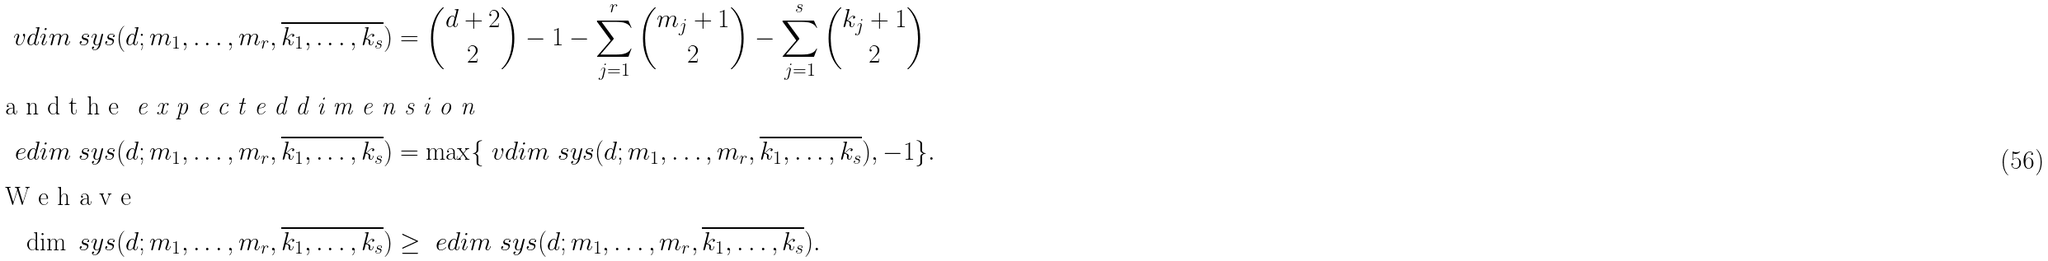Convert formula to latex. <formula><loc_0><loc_0><loc_500><loc_500>\ v d i m \ s y s ( d ; m _ { 1 } , \dots , m _ { r } , \overline { k _ { 1 } , \dots , k _ { s } } ) & = \binom { d + 2 } { 2 } - 1 - \sum _ { j = 1 } ^ { r } \binom { m _ { j } + 1 } { 2 } - \sum _ { j = 1 } ^ { s } \binom { k _ { j } + 1 } { 2 } \\ \intertext { a n d t h e \emph { e x p e c t e d d i m e n s i o n } } \ e d i m \ s y s ( d ; m _ { 1 } , \dots , m _ { r } , \overline { k _ { 1 } , \dots , k _ { s } } ) & = \max \{ \ v d i m \ s y s ( d ; m _ { 1 } , \dots , m _ { r } , \overline { k _ { 1 } , \dots , k _ { s } } ) , - 1 \} . \\ \intertext { W e h a v e } \dim \ s y s ( d ; m _ { 1 } , \dots , m _ { r } , \overline { k _ { 1 } , \dots , k _ { s } } ) & \geq \ e d i m \ s y s ( d ; m _ { 1 } , \dots , m _ { r } , \overline { k _ { 1 } , \dots , k _ { s } } ) .</formula> 